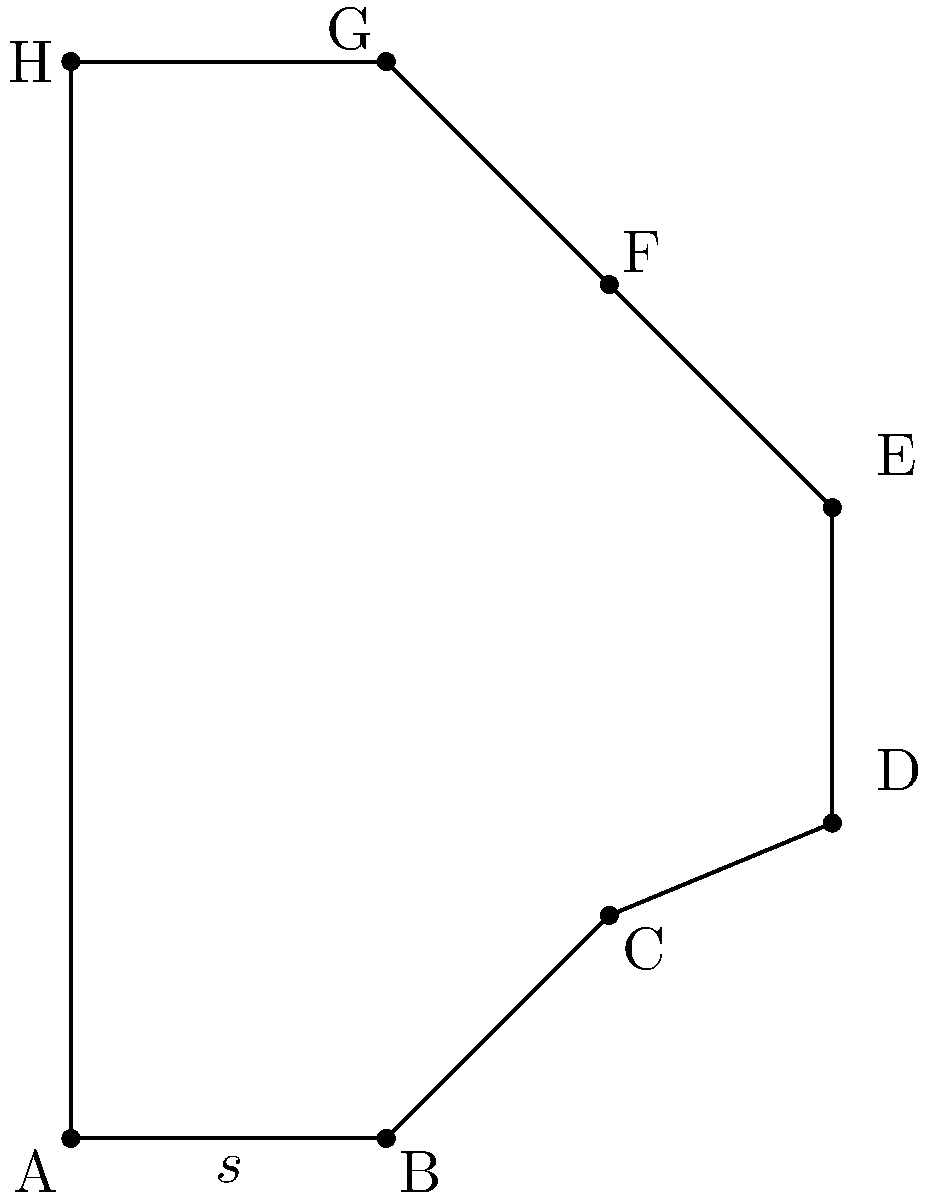In the context of geometric transformations, consider a regular octagon with side length $s$. Derive an expression for its perimeter in terms of $s$, and explain how this relates to the concept of symmetry in machine learning models like transformers. Let's approach this step-by-step:

1) First, recall that a regular octagon has 8 equal sides.

2) The perimeter of any polygon is the sum of the lengths of all its sides.

3) For a regular octagon with side length $s$, the perimeter $P$ is:

   $$P = 8s$$

4) This simple formula is a result of the octagon's rotational symmetry, which is analogous to the positional encoding in transformer models.

5) In transformers, positional encoding adds information about the position of each token in the sequence, similar to how each side of the octagon has a specific position but equal importance.

6) The self-attention mechanism in transformers can be thought of as creating relationships between all parts of the input, similar to how the perimeter connects all sides of the octagon.

7) Just as the octagon's perimeter is a linear function of its side length, transformers use linear projections in their attention mechanisms.

8) The regularity of the octagon (all sides being equal) is analogous to how transformers treat all input positions equally, allowing for parallel processing.

This geometric problem illustrates key concepts in transformers: symmetry, equal treatment of inputs, and the importance of positional information.
Answer: $P = 8s$ 